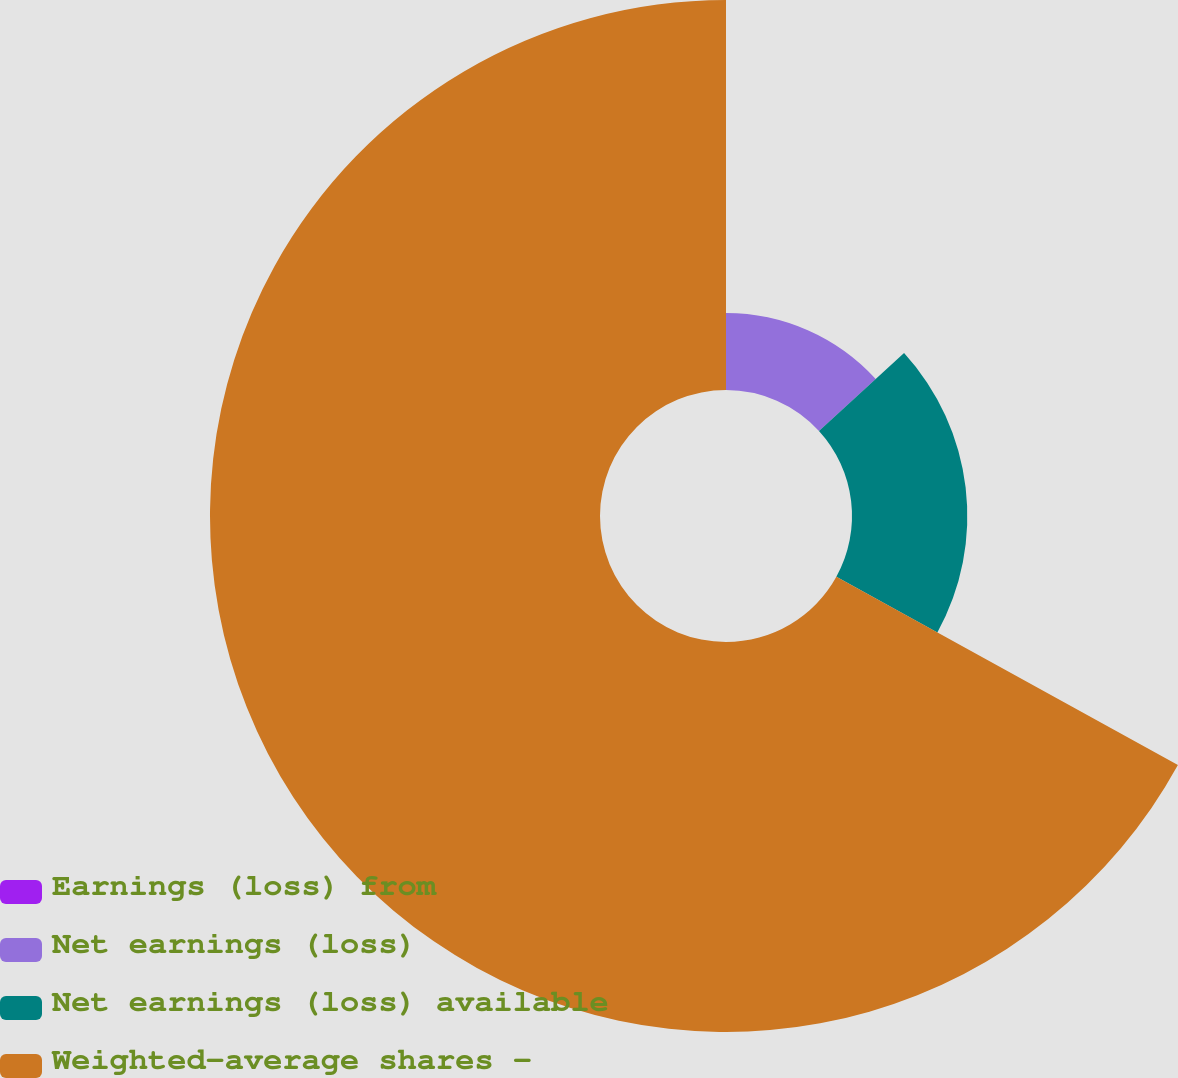<chart> <loc_0><loc_0><loc_500><loc_500><pie_chart><fcel>Earnings (loss) from<fcel>Net earnings (loss)<fcel>Net earnings (loss) available<fcel>Weighted-average shares -<nl><fcel>0.0%<fcel>13.21%<fcel>19.81%<fcel>66.99%<nl></chart> 